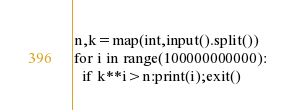Convert code to text. <code><loc_0><loc_0><loc_500><loc_500><_Python_>n,k=map(int,input().split())
for i in range(100000000000):
  if k**i>n:print(i);exit()</code> 